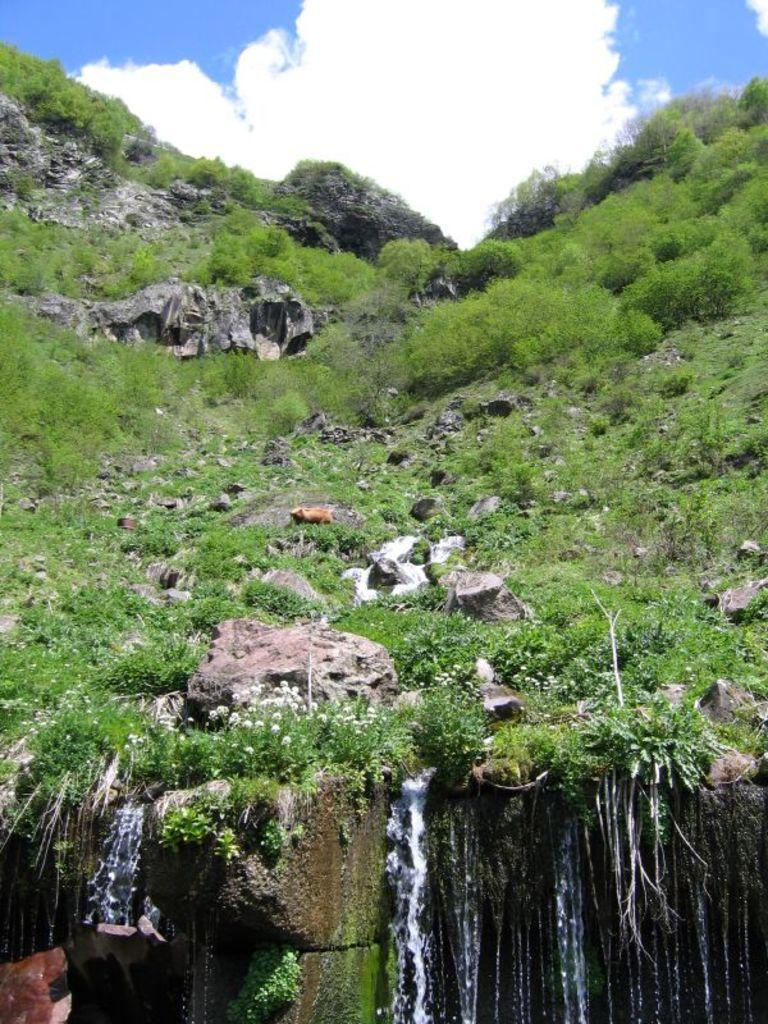What type of natural elements can be seen in the image? There are rocks and grass in the image. Are there any man-made objects present in the image? Yes, there are other objects in the image. What is the main feature at the bottom of the image? There is a waterfall at the bottom of the image. What is visible at the top of the image? The sky is visible at the top of the image. Can you see a key hanging from the rocks in the image? There is no key present in the image. Are there any dinosaurs grazing on the grass in the image? There are no dinosaurs present in the image; it is a natural landscape with rocks, grass, and a waterfall. 